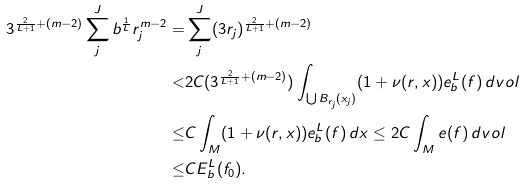Convert formula to latex. <formula><loc_0><loc_0><loc_500><loc_500>3 ^ { \frac { 2 } { L + 1 } + ( m - 2 ) } \sum _ { j } ^ { J } b ^ { \frac { 1 } { L } } r _ { j } ^ { m - 2 } = & \sum _ { j } ^ { J } ( 3 r _ { j } ) ^ { \frac { 2 } { L + 1 } + ( m - 2 ) } \\ < & 2 C ( 3 ^ { \frac { 2 } { L + 1 } + ( m - 2 ) } ) \int _ { \bigcup B _ { r _ { j } } ( x _ { j } ) } ( 1 + \nu ( r , x ) ) e _ { b } ^ { L } ( f ) \, d v o l \\ \leq & C \int _ { M } ( 1 + \nu ( r , x ) ) e _ { b } ^ { L } ( f ) \, d x \leq 2 C \int _ { M } e ( f ) \, d v o l \\ \leq & C E _ { b } ^ { L } ( f _ { 0 } ) .</formula> 